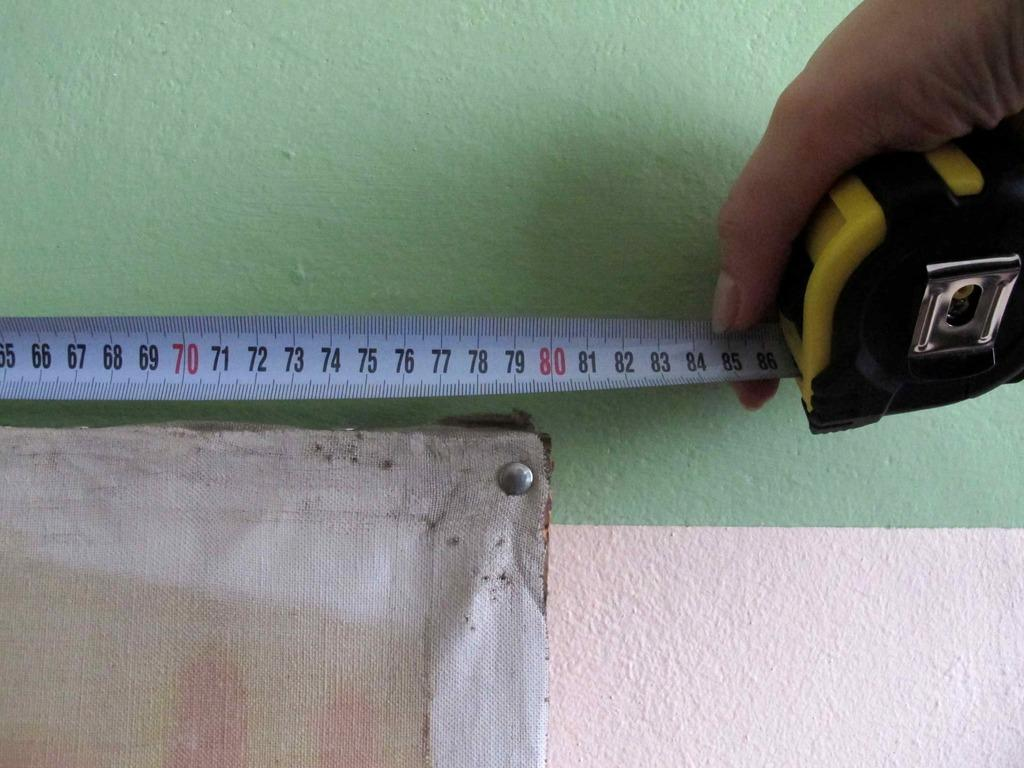<image>
Provide a brief description of the given image. A hand holds a measuring tape with the number 86 showing at the very end of the tape. 